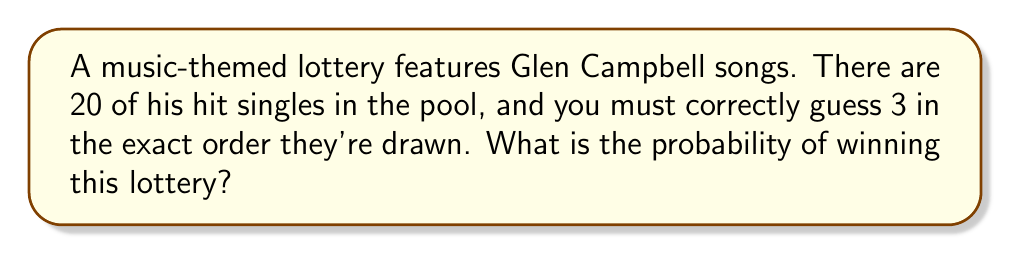Teach me how to tackle this problem. Let's approach this step-by-step:

1) This is a problem of permutation without replacement. We need to calculate the probability of correctly guessing the order of 3 songs out of 20.

2) For the first draw, we have 20 choices, for the second 19, and for the third 18.

3) The total number of possible outcomes (sample space) is:

   $$20 \times 19 \times 18 = 6840$$

4) The probability of winning is the number of favorable outcomes divided by the total number of possible outcomes. In this case, there's only one favorable outcome (the correct sequence of 3 songs).

5) Therefore, the probability is:

   $$P(\text{winning}) = \frac{1}{6840}$$

6) To express this as a decimal, we calculate:

   $$P(\text{winning}) = \frac{1}{6840} \approx 0.000146$$

7) As a percentage, this is approximately 0.0146%
Answer: $\frac{1}{6840}$ or approximately 0.000146 (0.0146%) 